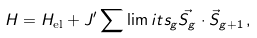<formula> <loc_0><loc_0><loc_500><loc_500>H = H _ { \text {el} } + J ^ { \prime } \sum \lim i t s _ { g } \vec { S _ { g } } \cdot \vec { S } _ { g + 1 } \, ,</formula> 